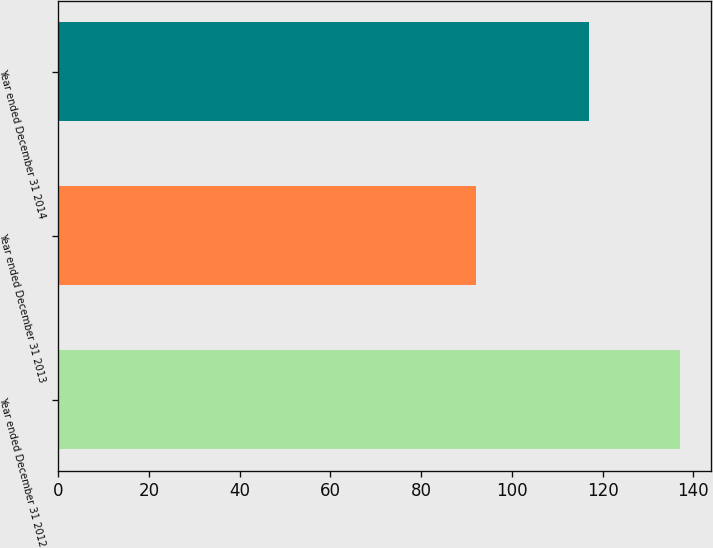<chart> <loc_0><loc_0><loc_500><loc_500><bar_chart><fcel>Year ended December 31 2012<fcel>Year ended December 31 2013<fcel>Year ended December 31 2014<nl><fcel>137<fcel>92<fcel>117<nl></chart> 